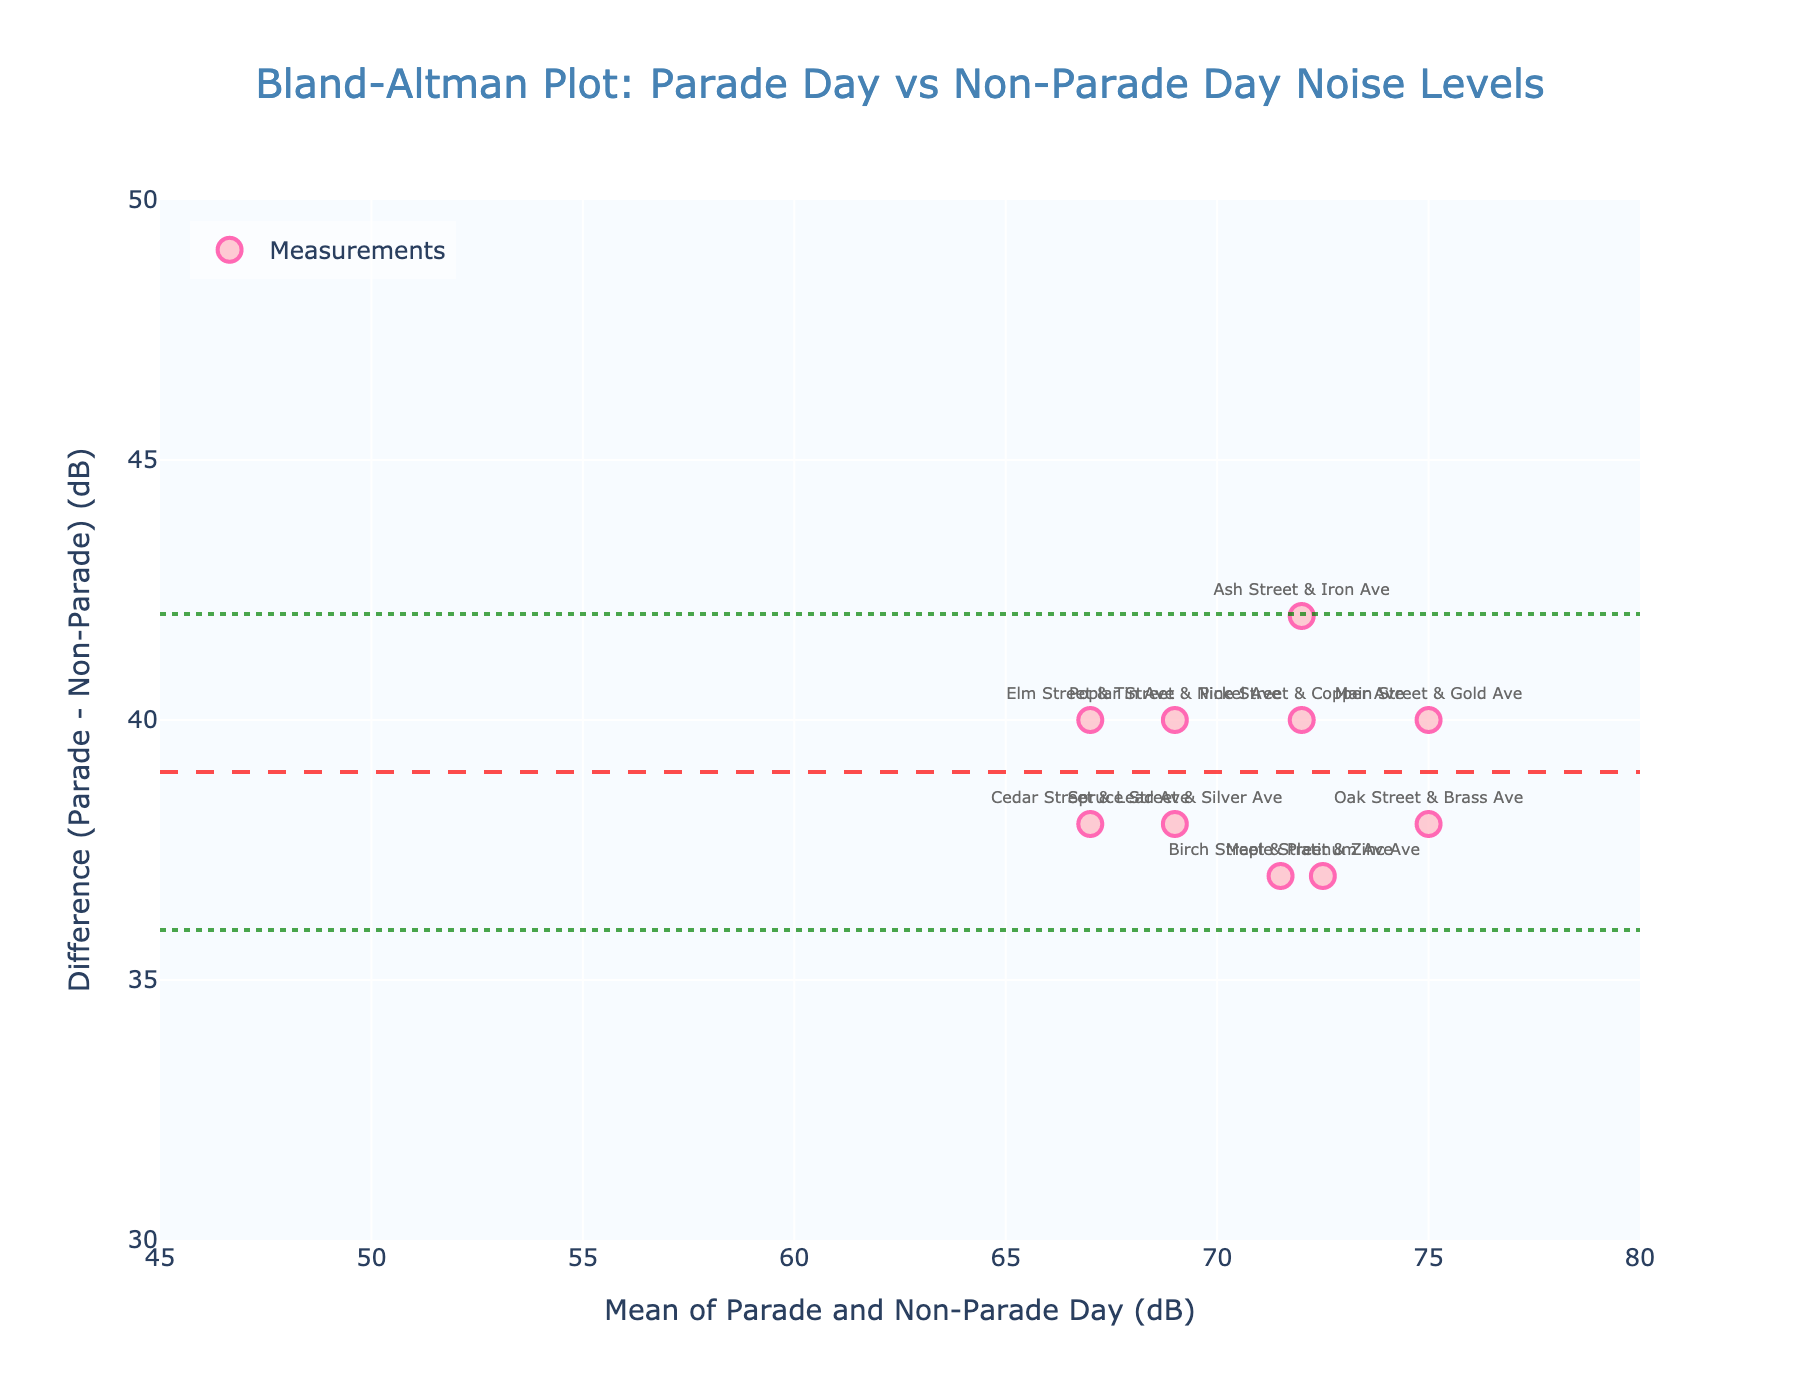Which location had the highest difference in noise levels? Look at the 'Difference' values plotted and find the maximum value. The highest difference is for "Main Street & Gold Ave" at 40 dB.
Answer: Main Street & Gold Ave What's the title of the plot? Read the title written on the plot. It is "Bland-Altman Plot: Parade Day vs Non-Parade Day Noise Levels".
Answer: Bland-Altman Plot: Parade Day vs Non-Parade Day Noise Levels How many data points are shown on the plot? Count the number of markers representing measurements on the plot. There are 10 data points.
Answer: 10 What is the mean difference in noise levels between parade and non-parade days? Refer to the horizontal line labeled 'Mean Difference' on the plot and note its value. The mean difference is approximately 38 dB.
Answer: 38 dB Which measurement has the smallest mean value of noise levels between parade and non-parade days? Identify the measurement with the smallest x-coordinate (Mean value) on the plot. The smallest mean value is for "Cedar Street & Lead Ave".
Answer: Cedar Street & Lead Ave What is the upper limit of agreement (LoA) on this plot? Locate and read the y-coordinate of the horizontal line labeled 'Upper LoA'. The upper limit of agreement is approximately 40 dB.
Answer: 40 dB What is the lower limit of agreement (LoA) on this plot? Locate and read the y-coordinate of the horizontal line labeled 'Lower LoA'. The lower limit of agreement is approximately 36 dB.
Answer: 36 dB Which measurement has the smallest difference in noise levels between parade and non-parade days? Identify the measurement with the smallest y-coordinate (Difference) on the plot. The smallest difference is for "Ash Street & Iron Ave".
Answer: Ash Street & Iron Ave How many measurements have a difference greater than 38 dB? Count the markers whose y-coordinates (Difference) are greater than 38 dB. There are 5 measurements.
Answer: 5 